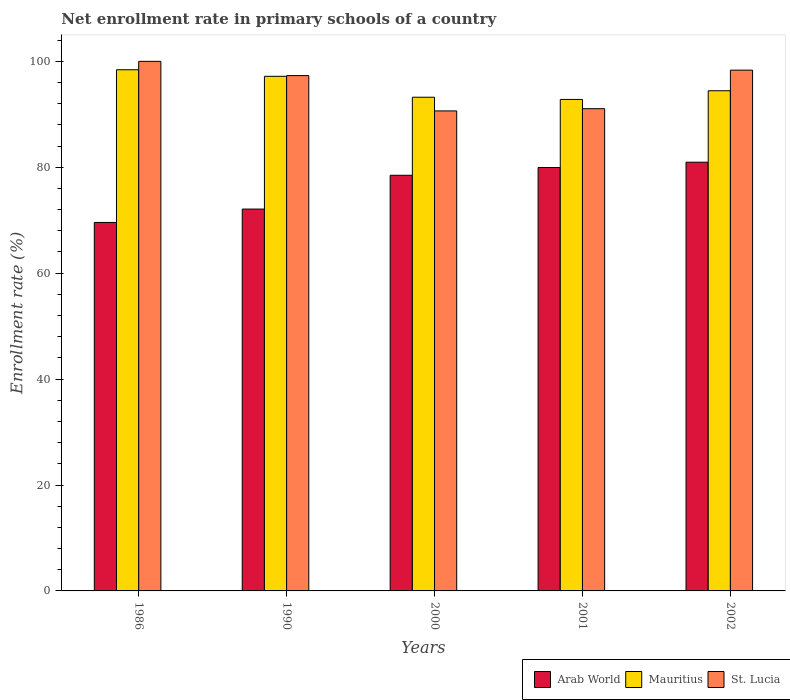How many groups of bars are there?
Make the answer very short. 5. Are the number of bars per tick equal to the number of legend labels?
Offer a very short reply. Yes. How many bars are there on the 1st tick from the left?
Provide a short and direct response. 3. How many bars are there on the 1st tick from the right?
Your answer should be very brief. 3. What is the enrollment rate in primary schools in Mauritius in 2002?
Make the answer very short. 94.45. Across all years, what is the minimum enrollment rate in primary schools in Mauritius?
Your answer should be compact. 92.81. What is the total enrollment rate in primary schools in St. Lucia in the graph?
Keep it short and to the point. 477.36. What is the difference between the enrollment rate in primary schools in Mauritius in 1990 and that in 2002?
Make the answer very short. 2.73. What is the difference between the enrollment rate in primary schools in St. Lucia in 2000 and the enrollment rate in primary schools in Mauritius in 1990?
Give a very brief answer. -6.54. What is the average enrollment rate in primary schools in St. Lucia per year?
Provide a succinct answer. 95.47. In the year 2001, what is the difference between the enrollment rate in primary schools in Mauritius and enrollment rate in primary schools in St. Lucia?
Ensure brevity in your answer.  1.74. What is the ratio of the enrollment rate in primary schools in St. Lucia in 2001 to that in 2002?
Offer a terse response. 0.93. Is the enrollment rate in primary schools in St. Lucia in 1990 less than that in 2001?
Provide a short and direct response. No. What is the difference between the highest and the second highest enrollment rate in primary schools in Mauritius?
Offer a terse response. 1.24. What is the difference between the highest and the lowest enrollment rate in primary schools in St. Lucia?
Give a very brief answer. 9.36. Is the sum of the enrollment rate in primary schools in Mauritius in 1986 and 2000 greater than the maximum enrollment rate in primary schools in Arab World across all years?
Ensure brevity in your answer.  Yes. What does the 1st bar from the left in 2000 represents?
Ensure brevity in your answer.  Arab World. What does the 3rd bar from the right in 2000 represents?
Provide a succinct answer. Arab World. Is it the case that in every year, the sum of the enrollment rate in primary schools in Arab World and enrollment rate in primary schools in Mauritius is greater than the enrollment rate in primary schools in St. Lucia?
Provide a short and direct response. Yes. How many years are there in the graph?
Keep it short and to the point. 5. How are the legend labels stacked?
Provide a succinct answer. Horizontal. What is the title of the graph?
Give a very brief answer. Net enrollment rate in primary schools of a country. Does "High income: OECD" appear as one of the legend labels in the graph?
Give a very brief answer. No. What is the label or title of the X-axis?
Make the answer very short. Years. What is the label or title of the Y-axis?
Your response must be concise. Enrollment rate (%). What is the Enrollment rate (%) of Arab World in 1986?
Provide a short and direct response. 69.58. What is the Enrollment rate (%) of Mauritius in 1986?
Your answer should be very brief. 98.41. What is the Enrollment rate (%) of Arab World in 1990?
Your answer should be compact. 72.1. What is the Enrollment rate (%) in Mauritius in 1990?
Ensure brevity in your answer.  97.18. What is the Enrollment rate (%) in St. Lucia in 1990?
Keep it short and to the point. 97.31. What is the Enrollment rate (%) in Arab World in 2000?
Your answer should be compact. 78.49. What is the Enrollment rate (%) in Mauritius in 2000?
Provide a succinct answer. 93.23. What is the Enrollment rate (%) in St. Lucia in 2000?
Offer a very short reply. 90.64. What is the Enrollment rate (%) of Arab World in 2001?
Provide a succinct answer. 79.96. What is the Enrollment rate (%) in Mauritius in 2001?
Your answer should be very brief. 92.81. What is the Enrollment rate (%) in St. Lucia in 2001?
Your answer should be compact. 91.06. What is the Enrollment rate (%) of Arab World in 2002?
Your answer should be very brief. 80.95. What is the Enrollment rate (%) in Mauritius in 2002?
Provide a short and direct response. 94.45. What is the Enrollment rate (%) in St. Lucia in 2002?
Ensure brevity in your answer.  98.34. Across all years, what is the maximum Enrollment rate (%) in Arab World?
Ensure brevity in your answer.  80.95. Across all years, what is the maximum Enrollment rate (%) in Mauritius?
Make the answer very short. 98.41. Across all years, what is the minimum Enrollment rate (%) in Arab World?
Give a very brief answer. 69.58. Across all years, what is the minimum Enrollment rate (%) of Mauritius?
Keep it short and to the point. 92.81. Across all years, what is the minimum Enrollment rate (%) of St. Lucia?
Your answer should be very brief. 90.64. What is the total Enrollment rate (%) of Arab World in the graph?
Provide a succinct answer. 381.08. What is the total Enrollment rate (%) in Mauritius in the graph?
Your answer should be compact. 476.08. What is the total Enrollment rate (%) in St. Lucia in the graph?
Your answer should be compact. 477.36. What is the difference between the Enrollment rate (%) of Arab World in 1986 and that in 1990?
Offer a very short reply. -2.53. What is the difference between the Enrollment rate (%) in Mauritius in 1986 and that in 1990?
Offer a terse response. 1.24. What is the difference between the Enrollment rate (%) of St. Lucia in 1986 and that in 1990?
Ensure brevity in your answer.  2.69. What is the difference between the Enrollment rate (%) of Arab World in 1986 and that in 2000?
Your answer should be compact. -8.91. What is the difference between the Enrollment rate (%) of Mauritius in 1986 and that in 2000?
Keep it short and to the point. 5.19. What is the difference between the Enrollment rate (%) of St. Lucia in 1986 and that in 2000?
Keep it short and to the point. 9.36. What is the difference between the Enrollment rate (%) of Arab World in 1986 and that in 2001?
Your answer should be very brief. -10.38. What is the difference between the Enrollment rate (%) of Mauritius in 1986 and that in 2001?
Offer a very short reply. 5.6. What is the difference between the Enrollment rate (%) of St. Lucia in 1986 and that in 2001?
Your answer should be very brief. 8.94. What is the difference between the Enrollment rate (%) in Arab World in 1986 and that in 2002?
Keep it short and to the point. -11.38. What is the difference between the Enrollment rate (%) of Mauritius in 1986 and that in 2002?
Your answer should be compact. 3.97. What is the difference between the Enrollment rate (%) of St. Lucia in 1986 and that in 2002?
Your answer should be very brief. 1.66. What is the difference between the Enrollment rate (%) in Arab World in 1990 and that in 2000?
Offer a terse response. -6.38. What is the difference between the Enrollment rate (%) in Mauritius in 1990 and that in 2000?
Give a very brief answer. 3.95. What is the difference between the Enrollment rate (%) of St. Lucia in 1990 and that in 2000?
Give a very brief answer. 6.67. What is the difference between the Enrollment rate (%) of Arab World in 1990 and that in 2001?
Your answer should be compact. -7.85. What is the difference between the Enrollment rate (%) in Mauritius in 1990 and that in 2001?
Provide a short and direct response. 4.37. What is the difference between the Enrollment rate (%) in St. Lucia in 1990 and that in 2001?
Offer a very short reply. 6.24. What is the difference between the Enrollment rate (%) in Arab World in 1990 and that in 2002?
Your answer should be very brief. -8.85. What is the difference between the Enrollment rate (%) in Mauritius in 1990 and that in 2002?
Give a very brief answer. 2.73. What is the difference between the Enrollment rate (%) of St. Lucia in 1990 and that in 2002?
Give a very brief answer. -1.03. What is the difference between the Enrollment rate (%) in Arab World in 2000 and that in 2001?
Provide a short and direct response. -1.47. What is the difference between the Enrollment rate (%) in Mauritius in 2000 and that in 2001?
Offer a very short reply. 0.42. What is the difference between the Enrollment rate (%) of St. Lucia in 2000 and that in 2001?
Your answer should be compact. -0.42. What is the difference between the Enrollment rate (%) of Arab World in 2000 and that in 2002?
Offer a terse response. -2.47. What is the difference between the Enrollment rate (%) of Mauritius in 2000 and that in 2002?
Provide a short and direct response. -1.22. What is the difference between the Enrollment rate (%) in St. Lucia in 2000 and that in 2002?
Provide a succinct answer. -7.7. What is the difference between the Enrollment rate (%) in Arab World in 2001 and that in 2002?
Your answer should be compact. -1. What is the difference between the Enrollment rate (%) in Mauritius in 2001 and that in 2002?
Provide a succinct answer. -1.64. What is the difference between the Enrollment rate (%) in St. Lucia in 2001 and that in 2002?
Provide a succinct answer. -7.28. What is the difference between the Enrollment rate (%) of Arab World in 1986 and the Enrollment rate (%) of Mauritius in 1990?
Offer a very short reply. -27.6. What is the difference between the Enrollment rate (%) in Arab World in 1986 and the Enrollment rate (%) in St. Lucia in 1990?
Keep it short and to the point. -27.73. What is the difference between the Enrollment rate (%) in Mauritius in 1986 and the Enrollment rate (%) in St. Lucia in 1990?
Keep it short and to the point. 1.1. What is the difference between the Enrollment rate (%) in Arab World in 1986 and the Enrollment rate (%) in Mauritius in 2000?
Ensure brevity in your answer.  -23.65. What is the difference between the Enrollment rate (%) in Arab World in 1986 and the Enrollment rate (%) in St. Lucia in 2000?
Your answer should be compact. -21.06. What is the difference between the Enrollment rate (%) in Mauritius in 1986 and the Enrollment rate (%) in St. Lucia in 2000?
Your response must be concise. 7.77. What is the difference between the Enrollment rate (%) of Arab World in 1986 and the Enrollment rate (%) of Mauritius in 2001?
Keep it short and to the point. -23.23. What is the difference between the Enrollment rate (%) of Arab World in 1986 and the Enrollment rate (%) of St. Lucia in 2001?
Your answer should be compact. -21.49. What is the difference between the Enrollment rate (%) of Mauritius in 1986 and the Enrollment rate (%) of St. Lucia in 2001?
Offer a very short reply. 7.35. What is the difference between the Enrollment rate (%) of Arab World in 1986 and the Enrollment rate (%) of Mauritius in 2002?
Your answer should be compact. -24.87. What is the difference between the Enrollment rate (%) in Arab World in 1986 and the Enrollment rate (%) in St. Lucia in 2002?
Provide a short and direct response. -28.76. What is the difference between the Enrollment rate (%) of Mauritius in 1986 and the Enrollment rate (%) of St. Lucia in 2002?
Ensure brevity in your answer.  0.07. What is the difference between the Enrollment rate (%) in Arab World in 1990 and the Enrollment rate (%) in Mauritius in 2000?
Ensure brevity in your answer.  -21.12. What is the difference between the Enrollment rate (%) in Arab World in 1990 and the Enrollment rate (%) in St. Lucia in 2000?
Give a very brief answer. -18.54. What is the difference between the Enrollment rate (%) of Mauritius in 1990 and the Enrollment rate (%) of St. Lucia in 2000?
Give a very brief answer. 6.54. What is the difference between the Enrollment rate (%) of Arab World in 1990 and the Enrollment rate (%) of Mauritius in 2001?
Give a very brief answer. -20.7. What is the difference between the Enrollment rate (%) of Arab World in 1990 and the Enrollment rate (%) of St. Lucia in 2001?
Provide a short and direct response. -18.96. What is the difference between the Enrollment rate (%) of Mauritius in 1990 and the Enrollment rate (%) of St. Lucia in 2001?
Your answer should be compact. 6.11. What is the difference between the Enrollment rate (%) in Arab World in 1990 and the Enrollment rate (%) in Mauritius in 2002?
Offer a very short reply. -22.34. What is the difference between the Enrollment rate (%) in Arab World in 1990 and the Enrollment rate (%) in St. Lucia in 2002?
Keep it short and to the point. -26.24. What is the difference between the Enrollment rate (%) in Mauritius in 1990 and the Enrollment rate (%) in St. Lucia in 2002?
Ensure brevity in your answer.  -1.17. What is the difference between the Enrollment rate (%) in Arab World in 2000 and the Enrollment rate (%) in Mauritius in 2001?
Provide a short and direct response. -14.32. What is the difference between the Enrollment rate (%) of Arab World in 2000 and the Enrollment rate (%) of St. Lucia in 2001?
Provide a succinct answer. -12.58. What is the difference between the Enrollment rate (%) of Mauritius in 2000 and the Enrollment rate (%) of St. Lucia in 2001?
Your answer should be compact. 2.16. What is the difference between the Enrollment rate (%) of Arab World in 2000 and the Enrollment rate (%) of Mauritius in 2002?
Your answer should be compact. -15.96. What is the difference between the Enrollment rate (%) in Arab World in 2000 and the Enrollment rate (%) in St. Lucia in 2002?
Offer a very short reply. -19.85. What is the difference between the Enrollment rate (%) in Mauritius in 2000 and the Enrollment rate (%) in St. Lucia in 2002?
Ensure brevity in your answer.  -5.12. What is the difference between the Enrollment rate (%) in Arab World in 2001 and the Enrollment rate (%) in Mauritius in 2002?
Keep it short and to the point. -14.49. What is the difference between the Enrollment rate (%) in Arab World in 2001 and the Enrollment rate (%) in St. Lucia in 2002?
Your response must be concise. -18.39. What is the difference between the Enrollment rate (%) in Mauritius in 2001 and the Enrollment rate (%) in St. Lucia in 2002?
Give a very brief answer. -5.53. What is the average Enrollment rate (%) of Arab World per year?
Your response must be concise. 76.22. What is the average Enrollment rate (%) of Mauritius per year?
Make the answer very short. 95.22. What is the average Enrollment rate (%) of St. Lucia per year?
Your response must be concise. 95.47. In the year 1986, what is the difference between the Enrollment rate (%) of Arab World and Enrollment rate (%) of Mauritius?
Provide a short and direct response. -28.83. In the year 1986, what is the difference between the Enrollment rate (%) of Arab World and Enrollment rate (%) of St. Lucia?
Offer a very short reply. -30.42. In the year 1986, what is the difference between the Enrollment rate (%) in Mauritius and Enrollment rate (%) in St. Lucia?
Make the answer very short. -1.59. In the year 1990, what is the difference between the Enrollment rate (%) in Arab World and Enrollment rate (%) in Mauritius?
Ensure brevity in your answer.  -25.07. In the year 1990, what is the difference between the Enrollment rate (%) of Arab World and Enrollment rate (%) of St. Lucia?
Keep it short and to the point. -25.2. In the year 1990, what is the difference between the Enrollment rate (%) of Mauritius and Enrollment rate (%) of St. Lucia?
Offer a terse response. -0.13. In the year 2000, what is the difference between the Enrollment rate (%) in Arab World and Enrollment rate (%) in Mauritius?
Your response must be concise. -14.74. In the year 2000, what is the difference between the Enrollment rate (%) of Arab World and Enrollment rate (%) of St. Lucia?
Your answer should be very brief. -12.15. In the year 2000, what is the difference between the Enrollment rate (%) of Mauritius and Enrollment rate (%) of St. Lucia?
Provide a short and direct response. 2.59. In the year 2001, what is the difference between the Enrollment rate (%) of Arab World and Enrollment rate (%) of Mauritius?
Offer a very short reply. -12.85. In the year 2001, what is the difference between the Enrollment rate (%) of Arab World and Enrollment rate (%) of St. Lucia?
Provide a short and direct response. -11.11. In the year 2001, what is the difference between the Enrollment rate (%) in Mauritius and Enrollment rate (%) in St. Lucia?
Your response must be concise. 1.74. In the year 2002, what is the difference between the Enrollment rate (%) in Arab World and Enrollment rate (%) in Mauritius?
Provide a succinct answer. -13.49. In the year 2002, what is the difference between the Enrollment rate (%) in Arab World and Enrollment rate (%) in St. Lucia?
Ensure brevity in your answer.  -17.39. In the year 2002, what is the difference between the Enrollment rate (%) in Mauritius and Enrollment rate (%) in St. Lucia?
Your answer should be very brief. -3.9. What is the ratio of the Enrollment rate (%) in Arab World in 1986 to that in 1990?
Offer a terse response. 0.96. What is the ratio of the Enrollment rate (%) in Mauritius in 1986 to that in 1990?
Ensure brevity in your answer.  1.01. What is the ratio of the Enrollment rate (%) of St. Lucia in 1986 to that in 1990?
Offer a very short reply. 1.03. What is the ratio of the Enrollment rate (%) of Arab World in 1986 to that in 2000?
Provide a succinct answer. 0.89. What is the ratio of the Enrollment rate (%) in Mauritius in 1986 to that in 2000?
Keep it short and to the point. 1.06. What is the ratio of the Enrollment rate (%) of St. Lucia in 1986 to that in 2000?
Make the answer very short. 1.1. What is the ratio of the Enrollment rate (%) in Arab World in 1986 to that in 2001?
Your answer should be very brief. 0.87. What is the ratio of the Enrollment rate (%) of Mauritius in 1986 to that in 2001?
Offer a terse response. 1.06. What is the ratio of the Enrollment rate (%) in St. Lucia in 1986 to that in 2001?
Ensure brevity in your answer.  1.1. What is the ratio of the Enrollment rate (%) in Arab World in 1986 to that in 2002?
Give a very brief answer. 0.86. What is the ratio of the Enrollment rate (%) of Mauritius in 1986 to that in 2002?
Provide a short and direct response. 1.04. What is the ratio of the Enrollment rate (%) of St. Lucia in 1986 to that in 2002?
Give a very brief answer. 1.02. What is the ratio of the Enrollment rate (%) in Arab World in 1990 to that in 2000?
Offer a very short reply. 0.92. What is the ratio of the Enrollment rate (%) of Mauritius in 1990 to that in 2000?
Give a very brief answer. 1.04. What is the ratio of the Enrollment rate (%) in St. Lucia in 1990 to that in 2000?
Ensure brevity in your answer.  1.07. What is the ratio of the Enrollment rate (%) of Arab World in 1990 to that in 2001?
Offer a terse response. 0.9. What is the ratio of the Enrollment rate (%) of Mauritius in 1990 to that in 2001?
Ensure brevity in your answer.  1.05. What is the ratio of the Enrollment rate (%) of St. Lucia in 1990 to that in 2001?
Your response must be concise. 1.07. What is the ratio of the Enrollment rate (%) of Arab World in 1990 to that in 2002?
Make the answer very short. 0.89. What is the ratio of the Enrollment rate (%) of Mauritius in 1990 to that in 2002?
Keep it short and to the point. 1.03. What is the ratio of the Enrollment rate (%) in St. Lucia in 1990 to that in 2002?
Ensure brevity in your answer.  0.99. What is the ratio of the Enrollment rate (%) in Arab World in 2000 to that in 2001?
Make the answer very short. 0.98. What is the ratio of the Enrollment rate (%) in Mauritius in 2000 to that in 2001?
Your answer should be compact. 1. What is the ratio of the Enrollment rate (%) in Arab World in 2000 to that in 2002?
Make the answer very short. 0.97. What is the ratio of the Enrollment rate (%) in Mauritius in 2000 to that in 2002?
Keep it short and to the point. 0.99. What is the ratio of the Enrollment rate (%) of St. Lucia in 2000 to that in 2002?
Your response must be concise. 0.92. What is the ratio of the Enrollment rate (%) in Mauritius in 2001 to that in 2002?
Give a very brief answer. 0.98. What is the ratio of the Enrollment rate (%) of St. Lucia in 2001 to that in 2002?
Your answer should be very brief. 0.93. What is the difference between the highest and the second highest Enrollment rate (%) in Mauritius?
Your answer should be compact. 1.24. What is the difference between the highest and the second highest Enrollment rate (%) in St. Lucia?
Give a very brief answer. 1.66. What is the difference between the highest and the lowest Enrollment rate (%) of Arab World?
Give a very brief answer. 11.38. What is the difference between the highest and the lowest Enrollment rate (%) in Mauritius?
Offer a very short reply. 5.6. What is the difference between the highest and the lowest Enrollment rate (%) of St. Lucia?
Keep it short and to the point. 9.36. 